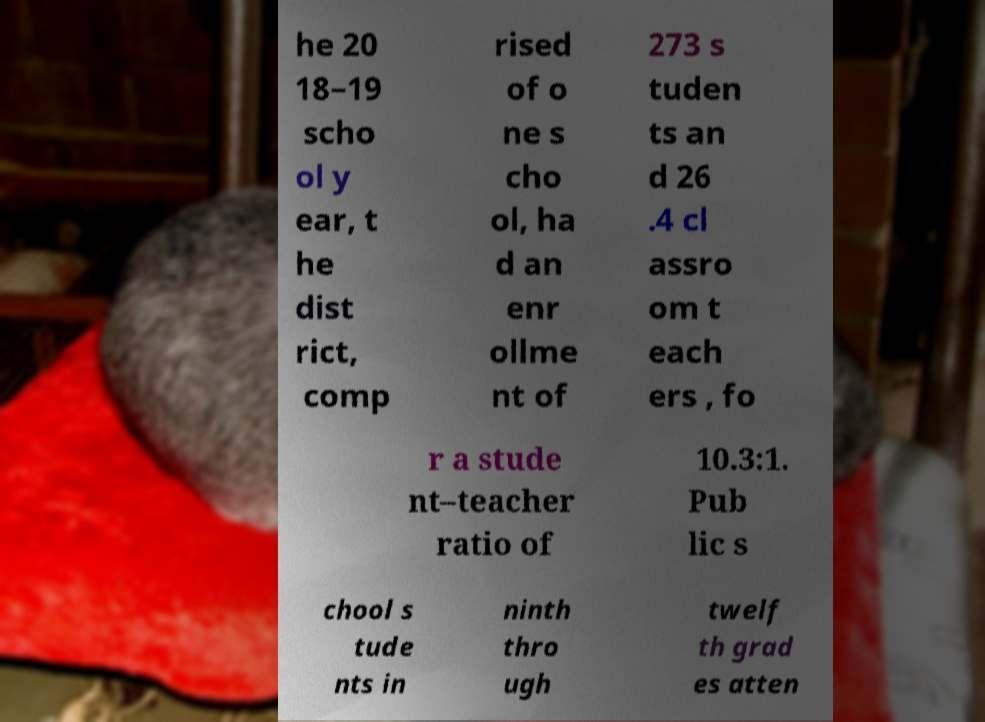There's text embedded in this image that I need extracted. Can you transcribe it verbatim? he 20 18–19 scho ol y ear, t he dist rict, comp rised of o ne s cho ol, ha d an enr ollme nt of 273 s tuden ts an d 26 .4 cl assro om t each ers , fo r a stude nt–teacher ratio of 10.3:1. Pub lic s chool s tude nts in ninth thro ugh twelf th grad es atten 